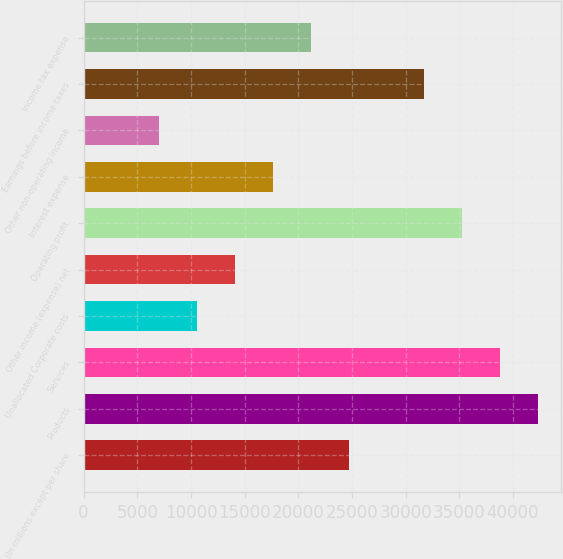Convert chart to OTSL. <chart><loc_0><loc_0><loc_500><loc_500><bar_chart><fcel>(In millions except per share<fcel>Products<fcel>Services<fcel>Unallocated Corporate costs<fcel>Other income (expense) net<fcel>Operating profit<fcel>Interest expense<fcel>Other non-operating income<fcel>Earnings before income taxes<fcel>Income tax expense<nl><fcel>24689<fcel>42319<fcel>38793<fcel>10585.1<fcel>14111.1<fcel>35267<fcel>17637<fcel>7059.08<fcel>31741<fcel>21163<nl></chart> 